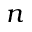Convert formula to latex. <formula><loc_0><loc_0><loc_500><loc_500>n</formula> 